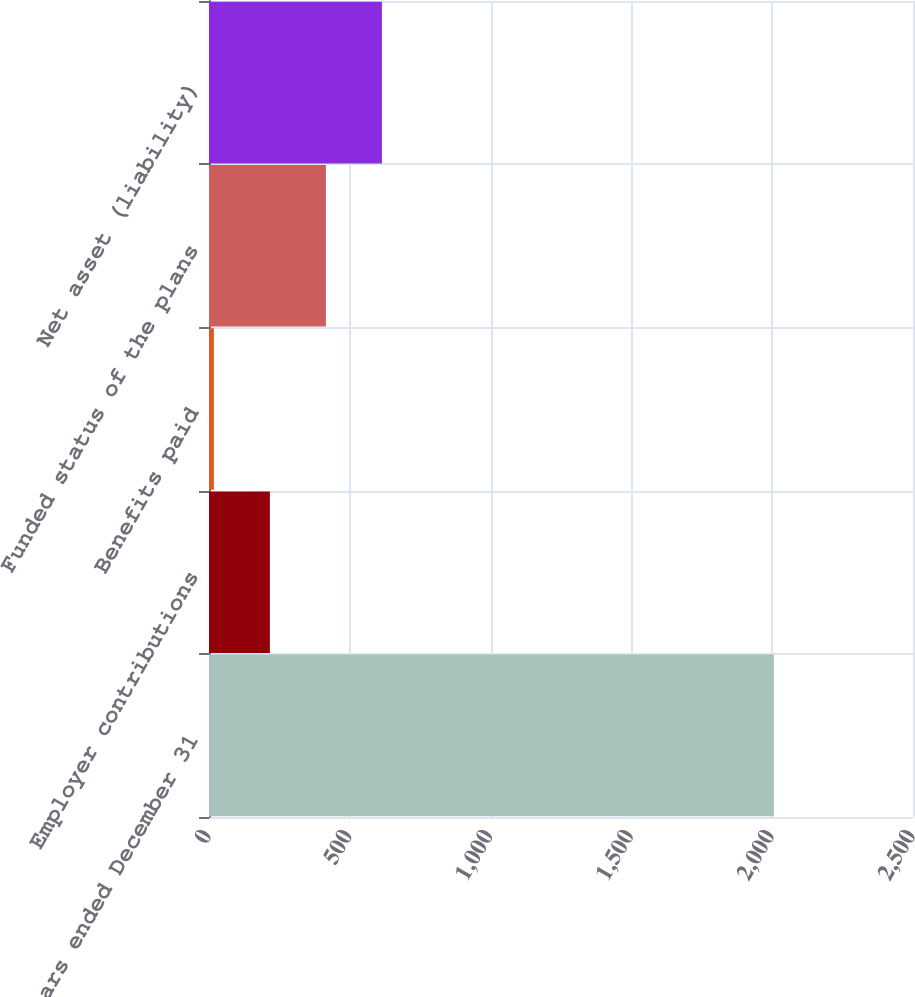<chart> <loc_0><loc_0><loc_500><loc_500><bar_chart><fcel>Years ended December 31<fcel>Employer contributions<fcel>Benefits paid<fcel>Funded status of the plans<fcel>Net asset (liability)<nl><fcel>2006<fcel>216.26<fcel>17.4<fcel>415.12<fcel>613.98<nl></chart> 